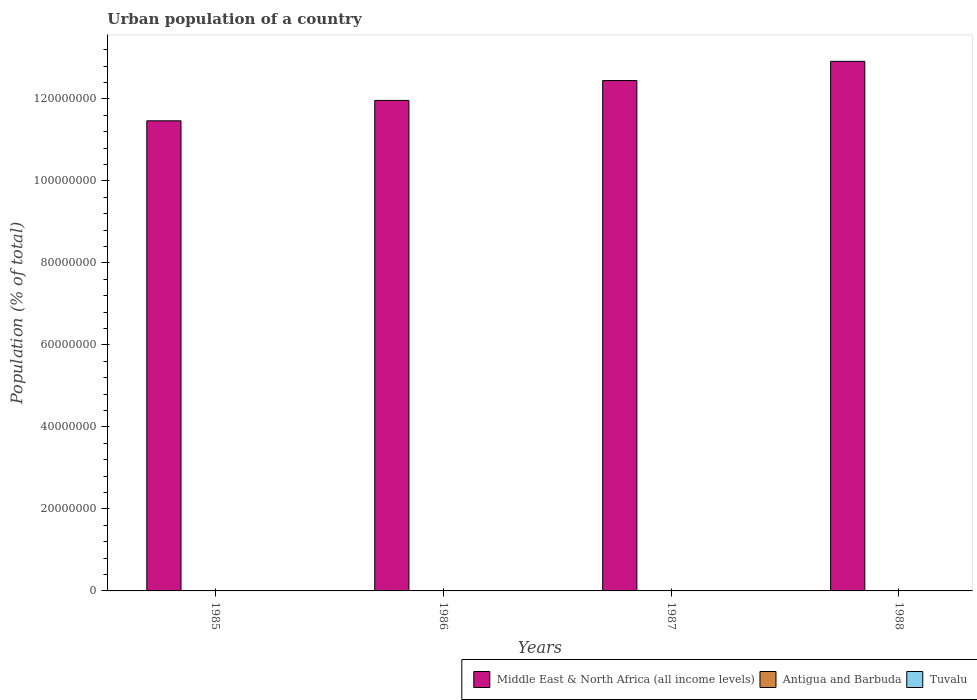How many different coloured bars are there?
Ensure brevity in your answer.  3. Are the number of bars on each tick of the X-axis equal?
Make the answer very short. Yes. How many bars are there on the 2nd tick from the left?
Your response must be concise. 3. How many bars are there on the 3rd tick from the right?
Make the answer very short. 3. In how many cases, is the number of bars for a given year not equal to the number of legend labels?
Your answer should be compact. 0. What is the urban population in Middle East & North Africa (all income levels) in 1988?
Give a very brief answer. 1.29e+08. Across all years, what is the maximum urban population in Middle East & North Africa (all income levels)?
Provide a short and direct response. 1.29e+08. Across all years, what is the minimum urban population in Middle East & North Africa (all income levels)?
Keep it short and to the point. 1.15e+08. In which year was the urban population in Middle East & North Africa (all income levels) maximum?
Make the answer very short. 1988. In which year was the urban population in Tuvalu minimum?
Offer a terse response. 1985. What is the total urban population in Antigua and Barbuda in the graph?
Keep it short and to the point. 9.01e+04. What is the difference between the urban population in Antigua and Barbuda in 1985 and that in 1988?
Provide a short and direct response. 971. What is the difference between the urban population in Middle East & North Africa (all income levels) in 1986 and the urban population in Tuvalu in 1985?
Give a very brief answer. 1.20e+08. What is the average urban population in Tuvalu per year?
Your answer should be very brief. 3172.5. In the year 1987, what is the difference between the urban population in Tuvalu and urban population in Antigua and Barbuda?
Keep it short and to the point. -1.91e+04. In how many years, is the urban population in Antigua and Barbuda greater than 64000000 %?
Provide a short and direct response. 0. What is the ratio of the urban population in Tuvalu in 1985 to that in 1988?
Your answer should be compact. 0.88. What is the difference between the highest and the second highest urban population in Tuvalu?
Give a very brief answer. 139. What is the difference between the highest and the lowest urban population in Tuvalu?
Provide a short and direct response. 420. In how many years, is the urban population in Middle East & North Africa (all income levels) greater than the average urban population in Middle East & North Africa (all income levels) taken over all years?
Your response must be concise. 2. Is the sum of the urban population in Middle East & North Africa (all income levels) in 1986 and 1987 greater than the maximum urban population in Antigua and Barbuda across all years?
Offer a terse response. Yes. What does the 3rd bar from the left in 1988 represents?
Make the answer very short. Tuvalu. What does the 3rd bar from the right in 1987 represents?
Your answer should be very brief. Middle East & North Africa (all income levels). How many bars are there?
Offer a terse response. 12. What is the difference between two consecutive major ticks on the Y-axis?
Your answer should be compact. 2.00e+07. Are the values on the major ticks of Y-axis written in scientific E-notation?
Provide a short and direct response. No. Where does the legend appear in the graph?
Provide a short and direct response. Bottom right. How many legend labels are there?
Provide a succinct answer. 3. What is the title of the graph?
Make the answer very short. Urban population of a country. What is the label or title of the X-axis?
Offer a very short reply. Years. What is the label or title of the Y-axis?
Offer a very short reply. Population (% of total). What is the Population (% of total) in Middle East & North Africa (all income levels) in 1985?
Your answer should be very brief. 1.15e+08. What is the Population (% of total) of Antigua and Barbuda in 1985?
Your answer should be compact. 2.30e+04. What is the Population (% of total) of Tuvalu in 1985?
Make the answer very short. 2962. What is the Population (% of total) of Middle East & North Africa (all income levels) in 1986?
Provide a short and direct response. 1.20e+08. What is the Population (% of total) in Antigua and Barbuda in 1986?
Provide a succinct answer. 2.27e+04. What is the Population (% of total) of Tuvalu in 1986?
Provide a succinct answer. 3103. What is the Population (% of total) of Middle East & North Africa (all income levels) in 1987?
Your response must be concise. 1.24e+08. What is the Population (% of total) of Antigua and Barbuda in 1987?
Provide a succinct answer. 2.23e+04. What is the Population (% of total) in Tuvalu in 1987?
Your answer should be very brief. 3243. What is the Population (% of total) in Middle East & North Africa (all income levels) in 1988?
Offer a very short reply. 1.29e+08. What is the Population (% of total) in Antigua and Barbuda in 1988?
Provide a succinct answer. 2.21e+04. What is the Population (% of total) of Tuvalu in 1988?
Your answer should be very brief. 3382. Across all years, what is the maximum Population (% of total) of Middle East & North Africa (all income levels)?
Make the answer very short. 1.29e+08. Across all years, what is the maximum Population (% of total) of Antigua and Barbuda?
Your answer should be very brief. 2.30e+04. Across all years, what is the maximum Population (% of total) of Tuvalu?
Offer a terse response. 3382. Across all years, what is the minimum Population (% of total) of Middle East & North Africa (all income levels)?
Make the answer very short. 1.15e+08. Across all years, what is the minimum Population (% of total) of Antigua and Barbuda?
Ensure brevity in your answer.  2.21e+04. Across all years, what is the minimum Population (% of total) of Tuvalu?
Offer a terse response. 2962. What is the total Population (% of total) in Middle East & North Africa (all income levels) in the graph?
Provide a succinct answer. 4.88e+08. What is the total Population (% of total) in Antigua and Barbuda in the graph?
Your response must be concise. 9.01e+04. What is the total Population (% of total) of Tuvalu in the graph?
Your answer should be compact. 1.27e+04. What is the difference between the Population (% of total) in Middle East & North Africa (all income levels) in 1985 and that in 1986?
Keep it short and to the point. -4.97e+06. What is the difference between the Population (% of total) in Antigua and Barbuda in 1985 and that in 1986?
Give a very brief answer. 346. What is the difference between the Population (% of total) in Tuvalu in 1985 and that in 1986?
Offer a very short reply. -141. What is the difference between the Population (% of total) of Middle East & North Africa (all income levels) in 1985 and that in 1987?
Give a very brief answer. -9.82e+06. What is the difference between the Population (% of total) of Antigua and Barbuda in 1985 and that in 1987?
Offer a very short reply. 688. What is the difference between the Population (% of total) of Tuvalu in 1985 and that in 1987?
Your response must be concise. -281. What is the difference between the Population (% of total) in Middle East & North Africa (all income levels) in 1985 and that in 1988?
Your answer should be compact. -1.45e+07. What is the difference between the Population (% of total) of Antigua and Barbuda in 1985 and that in 1988?
Offer a terse response. 971. What is the difference between the Population (% of total) of Tuvalu in 1985 and that in 1988?
Your answer should be compact. -420. What is the difference between the Population (% of total) of Middle East & North Africa (all income levels) in 1986 and that in 1987?
Keep it short and to the point. -4.84e+06. What is the difference between the Population (% of total) in Antigua and Barbuda in 1986 and that in 1987?
Keep it short and to the point. 342. What is the difference between the Population (% of total) of Tuvalu in 1986 and that in 1987?
Your response must be concise. -140. What is the difference between the Population (% of total) in Middle East & North Africa (all income levels) in 1986 and that in 1988?
Your answer should be very brief. -9.53e+06. What is the difference between the Population (% of total) in Antigua and Barbuda in 1986 and that in 1988?
Give a very brief answer. 625. What is the difference between the Population (% of total) of Tuvalu in 1986 and that in 1988?
Offer a terse response. -279. What is the difference between the Population (% of total) of Middle East & North Africa (all income levels) in 1987 and that in 1988?
Your answer should be compact. -4.68e+06. What is the difference between the Population (% of total) in Antigua and Barbuda in 1987 and that in 1988?
Keep it short and to the point. 283. What is the difference between the Population (% of total) in Tuvalu in 1987 and that in 1988?
Provide a succinct answer. -139. What is the difference between the Population (% of total) of Middle East & North Africa (all income levels) in 1985 and the Population (% of total) of Antigua and Barbuda in 1986?
Your answer should be very brief. 1.15e+08. What is the difference between the Population (% of total) of Middle East & North Africa (all income levels) in 1985 and the Population (% of total) of Tuvalu in 1986?
Offer a very short reply. 1.15e+08. What is the difference between the Population (% of total) in Antigua and Barbuda in 1985 and the Population (% of total) in Tuvalu in 1986?
Your answer should be very brief. 1.99e+04. What is the difference between the Population (% of total) in Middle East & North Africa (all income levels) in 1985 and the Population (% of total) in Antigua and Barbuda in 1987?
Give a very brief answer. 1.15e+08. What is the difference between the Population (% of total) in Middle East & North Africa (all income levels) in 1985 and the Population (% of total) in Tuvalu in 1987?
Offer a very short reply. 1.15e+08. What is the difference between the Population (% of total) in Antigua and Barbuda in 1985 and the Population (% of total) in Tuvalu in 1987?
Provide a short and direct response. 1.98e+04. What is the difference between the Population (% of total) of Middle East & North Africa (all income levels) in 1985 and the Population (% of total) of Antigua and Barbuda in 1988?
Ensure brevity in your answer.  1.15e+08. What is the difference between the Population (% of total) of Middle East & North Africa (all income levels) in 1985 and the Population (% of total) of Tuvalu in 1988?
Keep it short and to the point. 1.15e+08. What is the difference between the Population (% of total) of Antigua and Barbuda in 1985 and the Population (% of total) of Tuvalu in 1988?
Make the answer very short. 1.96e+04. What is the difference between the Population (% of total) in Middle East & North Africa (all income levels) in 1986 and the Population (% of total) in Antigua and Barbuda in 1987?
Make the answer very short. 1.20e+08. What is the difference between the Population (% of total) of Middle East & North Africa (all income levels) in 1986 and the Population (% of total) of Tuvalu in 1987?
Ensure brevity in your answer.  1.20e+08. What is the difference between the Population (% of total) of Antigua and Barbuda in 1986 and the Population (% of total) of Tuvalu in 1987?
Ensure brevity in your answer.  1.94e+04. What is the difference between the Population (% of total) of Middle East & North Africa (all income levels) in 1986 and the Population (% of total) of Antigua and Barbuda in 1988?
Your answer should be very brief. 1.20e+08. What is the difference between the Population (% of total) of Middle East & North Africa (all income levels) in 1986 and the Population (% of total) of Tuvalu in 1988?
Provide a succinct answer. 1.20e+08. What is the difference between the Population (% of total) of Antigua and Barbuda in 1986 and the Population (% of total) of Tuvalu in 1988?
Your answer should be compact. 1.93e+04. What is the difference between the Population (% of total) in Middle East & North Africa (all income levels) in 1987 and the Population (% of total) in Antigua and Barbuda in 1988?
Your response must be concise. 1.24e+08. What is the difference between the Population (% of total) in Middle East & North Africa (all income levels) in 1987 and the Population (% of total) in Tuvalu in 1988?
Provide a succinct answer. 1.24e+08. What is the difference between the Population (% of total) of Antigua and Barbuda in 1987 and the Population (% of total) of Tuvalu in 1988?
Offer a terse response. 1.90e+04. What is the average Population (% of total) of Middle East & North Africa (all income levels) per year?
Your answer should be compact. 1.22e+08. What is the average Population (% of total) in Antigua and Barbuda per year?
Make the answer very short. 2.25e+04. What is the average Population (% of total) in Tuvalu per year?
Offer a very short reply. 3172.5. In the year 1985, what is the difference between the Population (% of total) in Middle East & North Africa (all income levels) and Population (% of total) in Antigua and Barbuda?
Provide a short and direct response. 1.15e+08. In the year 1985, what is the difference between the Population (% of total) of Middle East & North Africa (all income levels) and Population (% of total) of Tuvalu?
Your answer should be very brief. 1.15e+08. In the year 1985, what is the difference between the Population (% of total) of Antigua and Barbuda and Population (% of total) of Tuvalu?
Give a very brief answer. 2.01e+04. In the year 1986, what is the difference between the Population (% of total) of Middle East & North Africa (all income levels) and Population (% of total) of Antigua and Barbuda?
Give a very brief answer. 1.20e+08. In the year 1986, what is the difference between the Population (% of total) of Middle East & North Africa (all income levels) and Population (% of total) of Tuvalu?
Offer a terse response. 1.20e+08. In the year 1986, what is the difference between the Population (% of total) of Antigua and Barbuda and Population (% of total) of Tuvalu?
Provide a short and direct response. 1.96e+04. In the year 1987, what is the difference between the Population (% of total) in Middle East & North Africa (all income levels) and Population (% of total) in Antigua and Barbuda?
Keep it short and to the point. 1.24e+08. In the year 1987, what is the difference between the Population (% of total) in Middle East & North Africa (all income levels) and Population (% of total) in Tuvalu?
Ensure brevity in your answer.  1.24e+08. In the year 1987, what is the difference between the Population (% of total) of Antigua and Barbuda and Population (% of total) of Tuvalu?
Offer a terse response. 1.91e+04. In the year 1988, what is the difference between the Population (% of total) in Middle East & North Africa (all income levels) and Population (% of total) in Antigua and Barbuda?
Your response must be concise. 1.29e+08. In the year 1988, what is the difference between the Population (% of total) of Middle East & North Africa (all income levels) and Population (% of total) of Tuvalu?
Make the answer very short. 1.29e+08. In the year 1988, what is the difference between the Population (% of total) in Antigua and Barbuda and Population (% of total) in Tuvalu?
Your answer should be very brief. 1.87e+04. What is the ratio of the Population (% of total) in Middle East & North Africa (all income levels) in 1985 to that in 1986?
Your response must be concise. 0.96. What is the ratio of the Population (% of total) of Antigua and Barbuda in 1985 to that in 1986?
Make the answer very short. 1.02. What is the ratio of the Population (% of total) of Tuvalu in 1985 to that in 1986?
Provide a succinct answer. 0.95. What is the ratio of the Population (% of total) of Middle East & North Africa (all income levels) in 1985 to that in 1987?
Your answer should be compact. 0.92. What is the ratio of the Population (% of total) in Antigua and Barbuda in 1985 to that in 1987?
Keep it short and to the point. 1.03. What is the ratio of the Population (% of total) in Tuvalu in 1985 to that in 1987?
Provide a short and direct response. 0.91. What is the ratio of the Population (% of total) of Middle East & North Africa (all income levels) in 1985 to that in 1988?
Keep it short and to the point. 0.89. What is the ratio of the Population (% of total) in Antigua and Barbuda in 1985 to that in 1988?
Make the answer very short. 1.04. What is the ratio of the Population (% of total) of Tuvalu in 1985 to that in 1988?
Provide a succinct answer. 0.88. What is the ratio of the Population (% of total) of Middle East & North Africa (all income levels) in 1986 to that in 1987?
Your response must be concise. 0.96. What is the ratio of the Population (% of total) of Antigua and Barbuda in 1986 to that in 1987?
Keep it short and to the point. 1.02. What is the ratio of the Population (% of total) in Tuvalu in 1986 to that in 1987?
Give a very brief answer. 0.96. What is the ratio of the Population (% of total) in Middle East & North Africa (all income levels) in 1986 to that in 1988?
Offer a very short reply. 0.93. What is the ratio of the Population (% of total) of Antigua and Barbuda in 1986 to that in 1988?
Make the answer very short. 1.03. What is the ratio of the Population (% of total) of Tuvalu in 1986 to that in 1988?
Your answer should be compact. 0.92. What is the ratio of the Population (% of total) in Middle East & North Africa (all income levels) in 1987 to that in 1988?
Offer a terse response. 0.96. What is the ratio of the Population (% of total) in Antigua and Barbuda in 1987 to that in 1988?
Keep it short and to the point. 1.01. What is the ratio of the Population (% of total) of Tuvalu in 1987 to that in 1988?
Provide a succinct answer. 0.96. What is the difference between the highest and the second highest Population (% of total) of Middle East & North Africa (all income levels)?
Your answer should be very brief. 4.68e+06. What is the difference between the highest and the second highest Population (% of total) in Antigua and Barbuda?
Your answer should be very brief. 346. What is the difference between the highest and the second highest Population (% of total) of Tuvalu?
Offer a very short reply. 139. What is the difference between the highest and the lowest Population (% of total) of Middle East & North Africa (all income levels)?
Make the answer very short. 1.45e+07. What is the difference between the highest and the lowest Population (% of total) of Antigua and Barbuda?
Offer a very short reply. 971. What is the difference between the highest and the lowest Population (% of total) in Tuvalu?
Your answer should be compact. 420. 